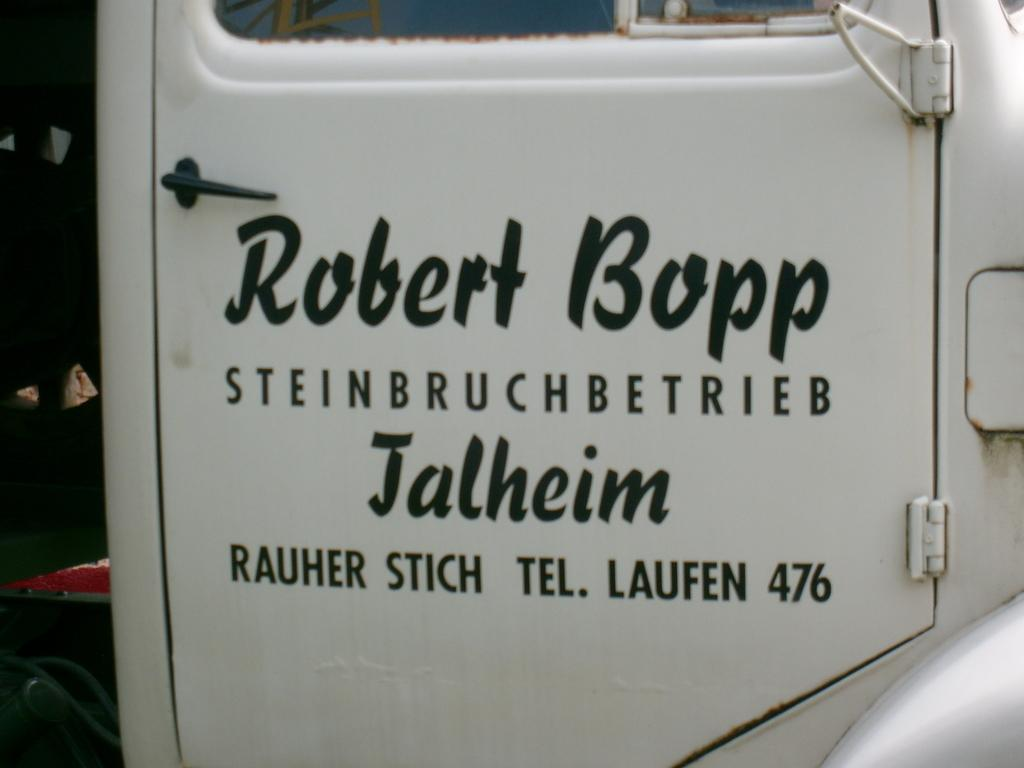What type of door is shown in the image? There is a white door in the image. What feature is present on the door? The door has a handle. What can be seen on the left side of the image? Pipes are visible on the left side bottom of the image. What is written or displayed on the door? There is text on the door. What object is located at the top of the image? There is a glass at the top of the image. How many babies are crawling on the door in the image? There are no babies present in the image; it only shows a white door with a handle, text, and pipes. 